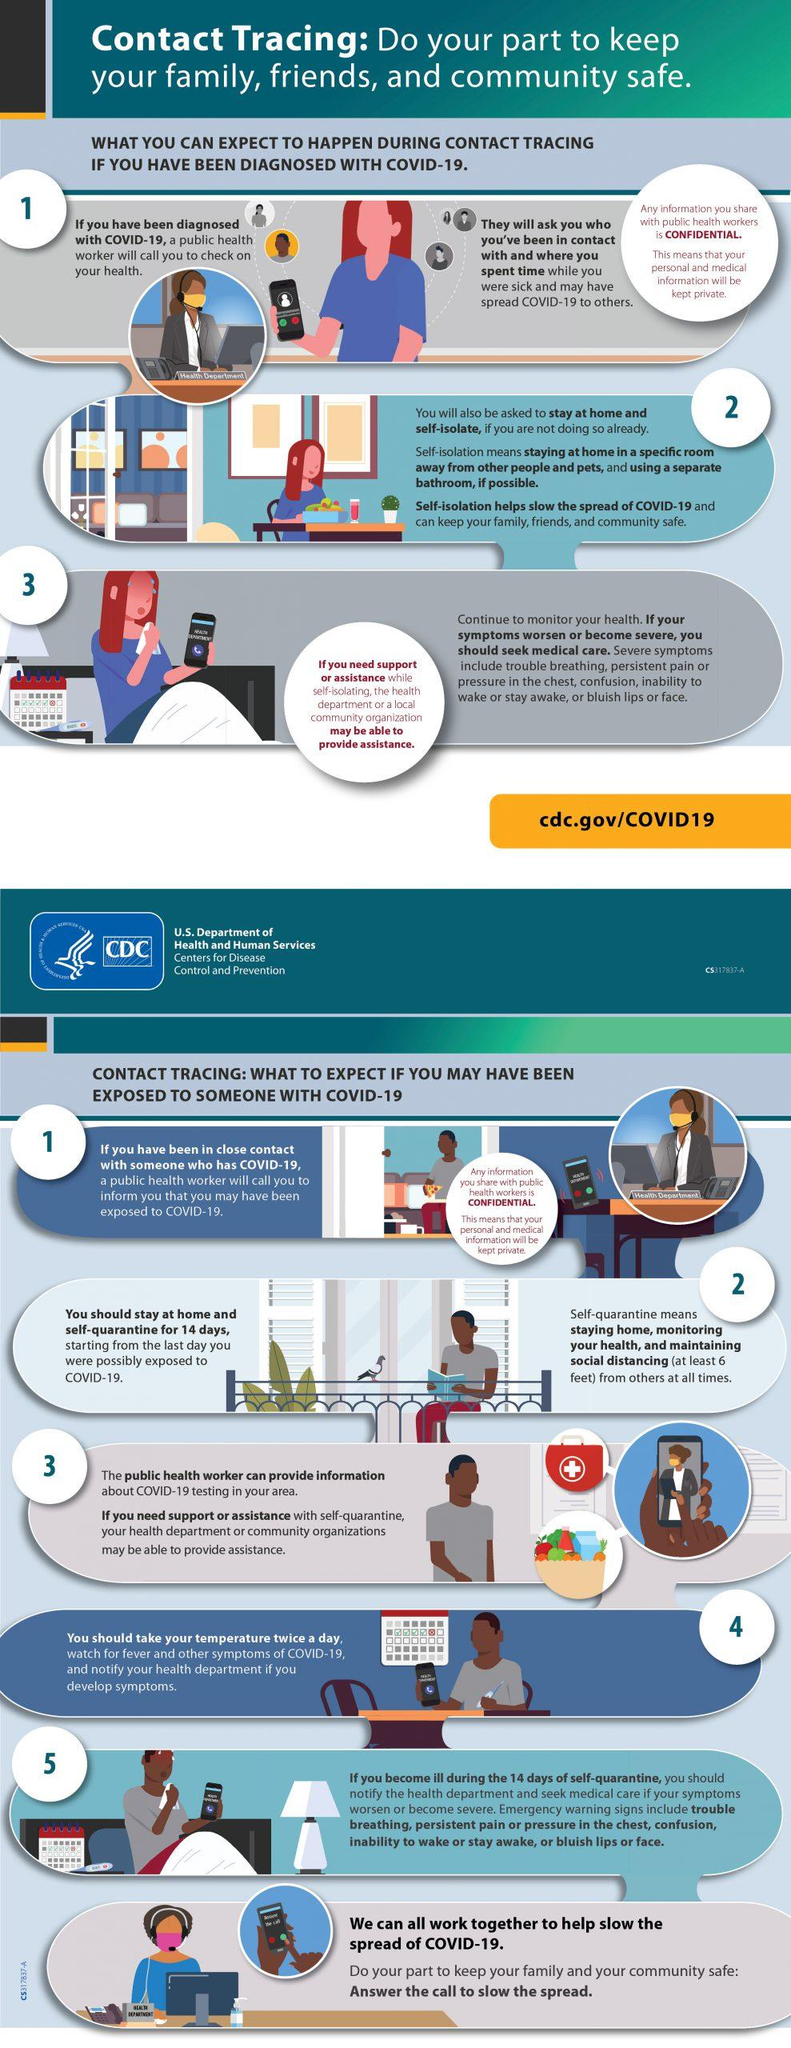Highlight a few significant elements in this photo. The number of individuals wearing masks in the infographic is 4. There are 7 mobile phones depicted in this infographic. It is estimated that 3 individuals are currently seated in front of their computers, as depicted in this infographic. There are three calendars featured in this infographic. 